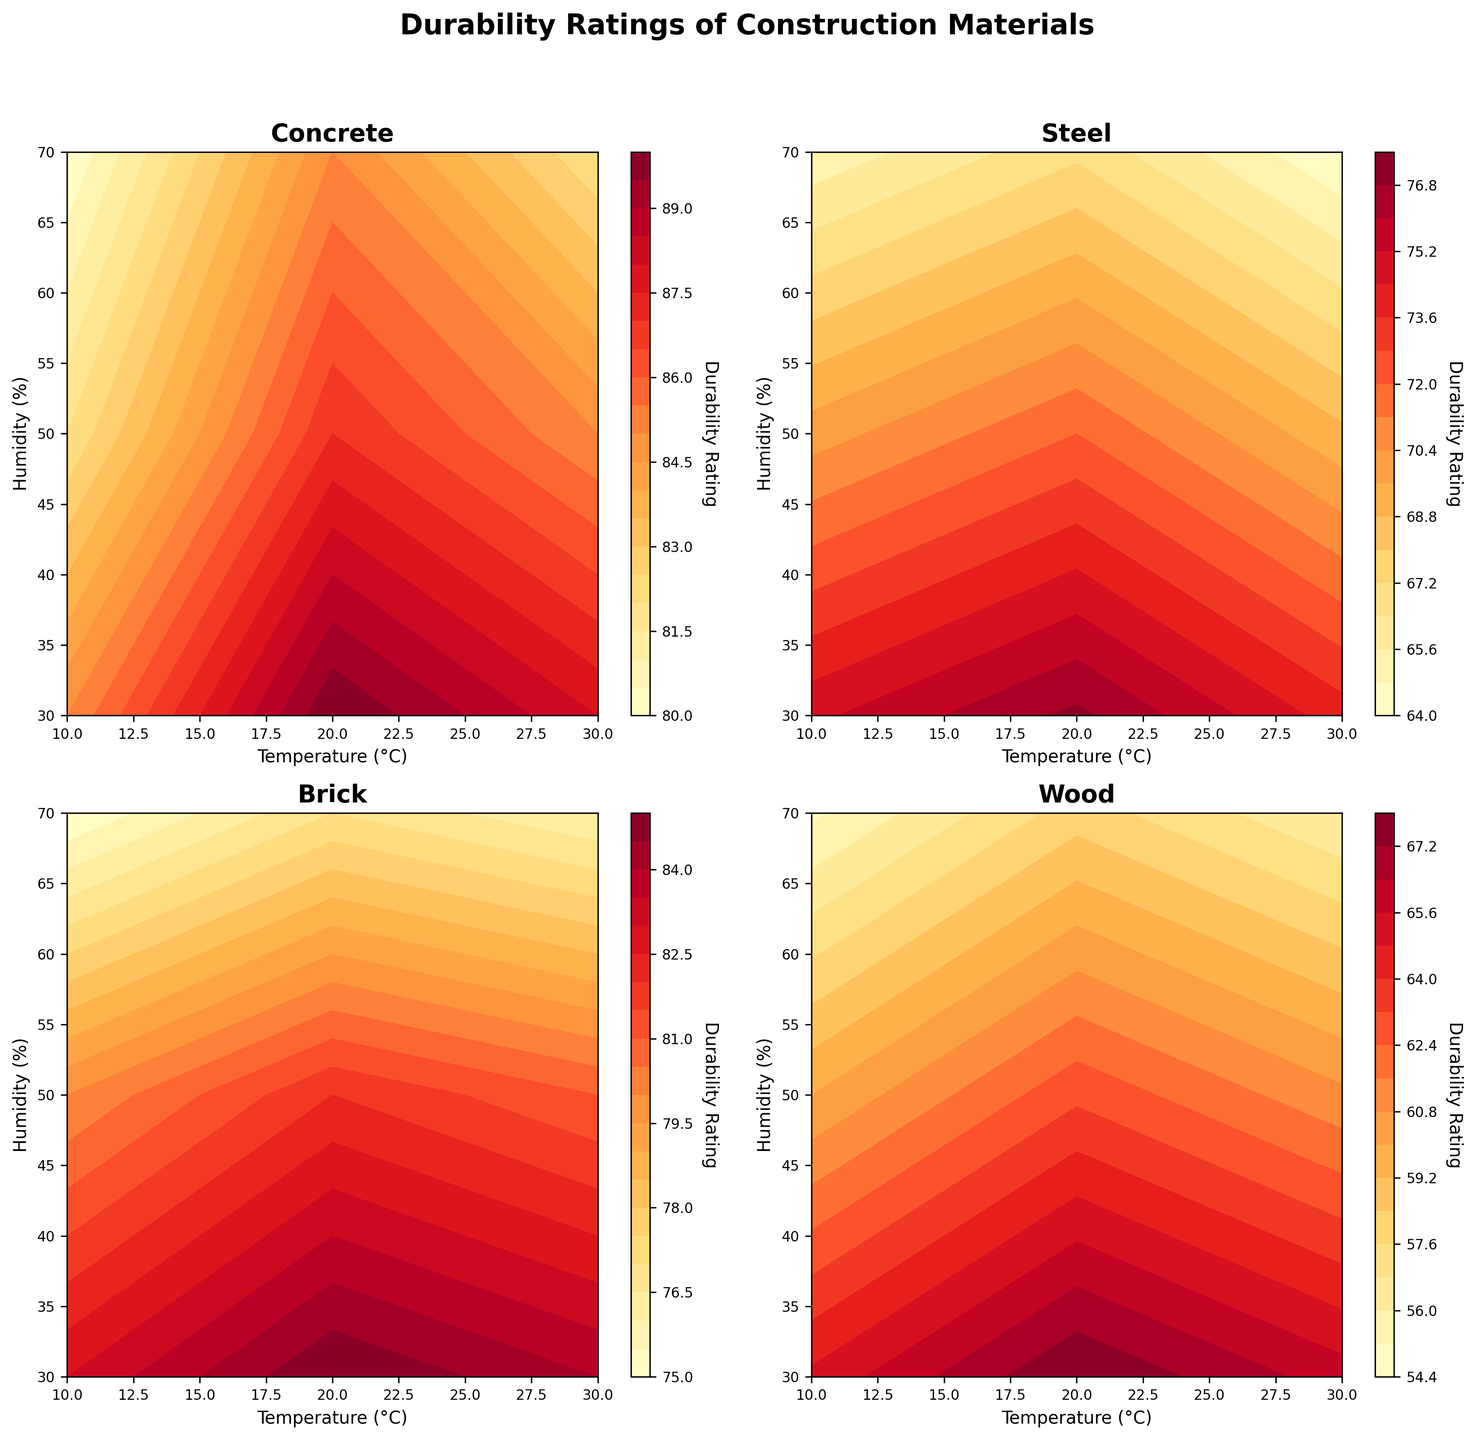What is the title of the figure? The title is located at the top center of the figure and reads "Durability Ratings of Construction Materials".
Answer: Durability Ratings of Construction Materials Which material has the highest durability rating according to the plot? By inspecting each subplot, observe that Concrete has the highest durability rating of 90 at a temperature of 20°C and humidity of 30%.
Answer: Concrete How does the durability of wood change with increasing temperature and humidity? Look at the contours in the Wood subplot. The durability rating decreases from 65 to 55 as both temperature and humidity increase.
Answer: Decreases In which subplot do we find the most variation in durability ratings? Check the range of contour levels in each subplot. The Steel subplot, with durability ratings ranging from 64 to 77, shows the most variability.
Answer: Steel Which material shows the least sensitivity to changes in humidity at a temperature of 10°C? In the subplot for Concrete, observe that the durability ratings are very close (only a difference of 5) as humidity changes from 30% to 70%.
Answer: Concrete What is the durability rating of Brick at a temperature of 20°C and humidity of 50%? Locate the specific contour level in the Brick subplot at the intersection of 20°C and 50% humidity. The durability rating there is 82.
Answer: 82 Compare the durability ratings of Steel and Wood at 30°C and 50% Humidity? Find the durability rating for each material at these conditions. For Steel, it is 69; for Wood, it is 61. Steel has a higher rating.
Answer: Steel: 69, Wood: 61 Which material maintains a durability rating above 80 across all temperatures and humidity levels? Examine each subplot to see if any material consistently stays above the 80 level. Concrete is the only material meeting this condition.
Answer: Concrete If one wants to maximize the durability of building materials under high humidity conditions, which material should be chosen? Considering the durability ratings at higher humidities (70%) for all materials, Concrete shows the highest durability ratings (80-85).
Answer: Concrete What is the average durability rating of Brick across all temperature and humidity levels? To find this, sum all Brick durability ratings (83, 80, 75, 85, 82, 77, 84, 81, 76) and divide by the number of data points (9). This results in an average rating of 80.3.
Answer: 80.3 